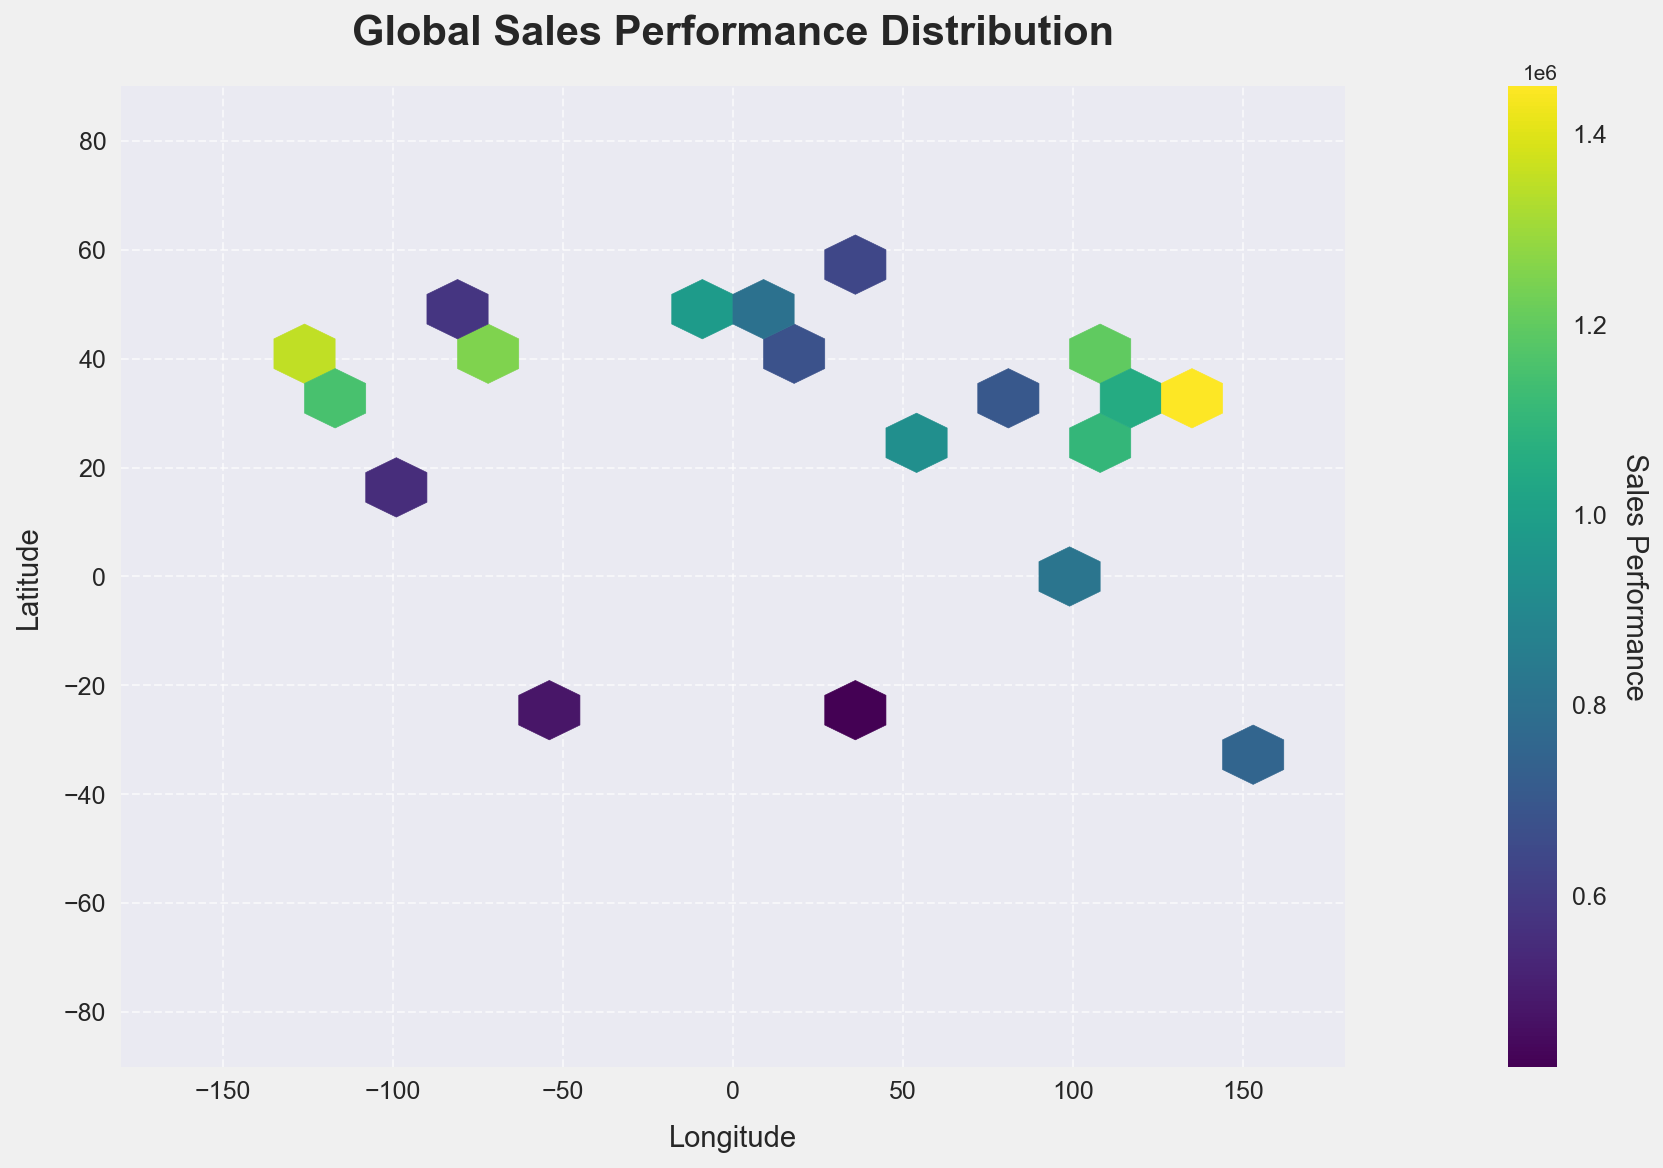What is the title of the hexbin plot? The title is usually located at the top of the plot, typically in a larger and bolder font to make it stand out. Look at the top part of the plot for the title.
Answer: Global Sales Performance Distribution What do the x-axis and y-axis represent in this plot? The x-axis represents longitude, and the y-axis represents latitude. This can be inferred from the axis labels provided along the axes, indicating the geographic coordinates.
Answer: Longitude and Latitude Which color represents the highest sales performance in the plot? In a hexbin plot with a color gradient, the color corresponding to the highest value is usually the brightest or most intense. In this figure, we need to look for the color at the maximum end of the color bar.
Answer: Bright green What is the range of sales performance values shown on the color bar? By examining the color legend on the right side of the plot, you can see both the minimum and maximum values indicated. These represent the range of sales performance values.
Answer: 420,000 to 1,450,000 Where are the highest sales performances geographically located? High sales performances are indicated by the brightest (most intense) colors in the hexbin plot. Analyze the regions with the brightest colors and note their approximate coordinates.
Answer: Near Tokyo, New York, and San Francisco Which geographic location has the lowest sales performance? The lowest sales performance is represented by the darkest color in the hexbin plot. Identify the hexbin with the darkest color and note its geographic coordinates.
Answer: Near Johannesburg What is the sales performance range in the cities of Europe represented in the plot? European cities on the plot include London, Paris, Rome, and Berlin. Check the color of the bins in these regions and refer to the color bar to estimate the sales performance range.
Answer: 640,000 to 980,000 Which hemisphere appears to have better sales performance, Eastern or Western? The plot is divided into Eastern (longitudes 0 to 180) and Western (longitudes -180 to 0) hemispheres. Compare the color intensity of hexagons in both hemispheres to determine which has better sales performance.
Answer: Eastern Hemisphere Are there more high-performing sales locations in the Northern or Southern Hemisphere? The Northern Hemisphere spans latitudes 0 to 90, and the Southern Hemisphere includes latitudes 0 to -90. Compare the density and intensity of hexagons in both hemispheres to determine where higher sales performance is concentrated.
Answer: Northern Hemisphere How widely is the sales performance distributed across different longitudes? By observing the spread of data points along the x-axis (longitude), we can determine the geographic distribution width-wise. The presence of hexagons across the full range of the x-axis indicates a wide distribution.
Answer: Widely distributed across longitudes 